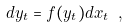Convert formula to latex. <formula><loc_0><loc_0><loc_500><loc_500>d y _ { t } = f ( y _ { t } ) d x _ { t } \ ,</formula> 